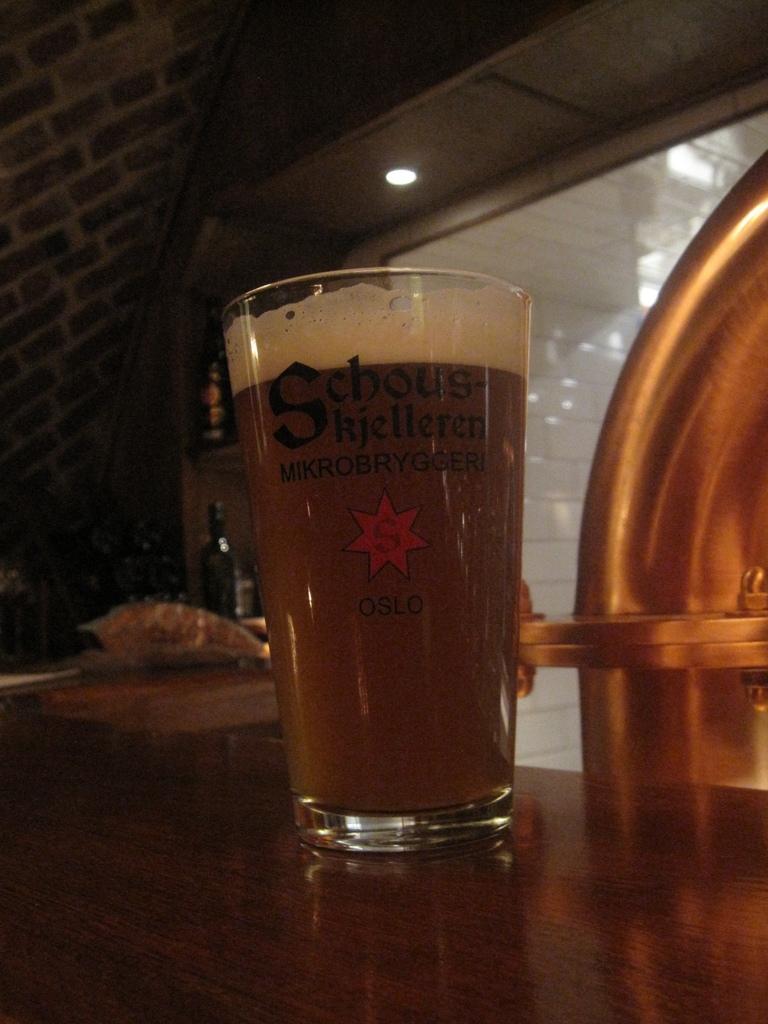What letter is seen in the red star?
Offer a very short reply. S. What's the large letter on the glass?
Your response must be concise. S. 